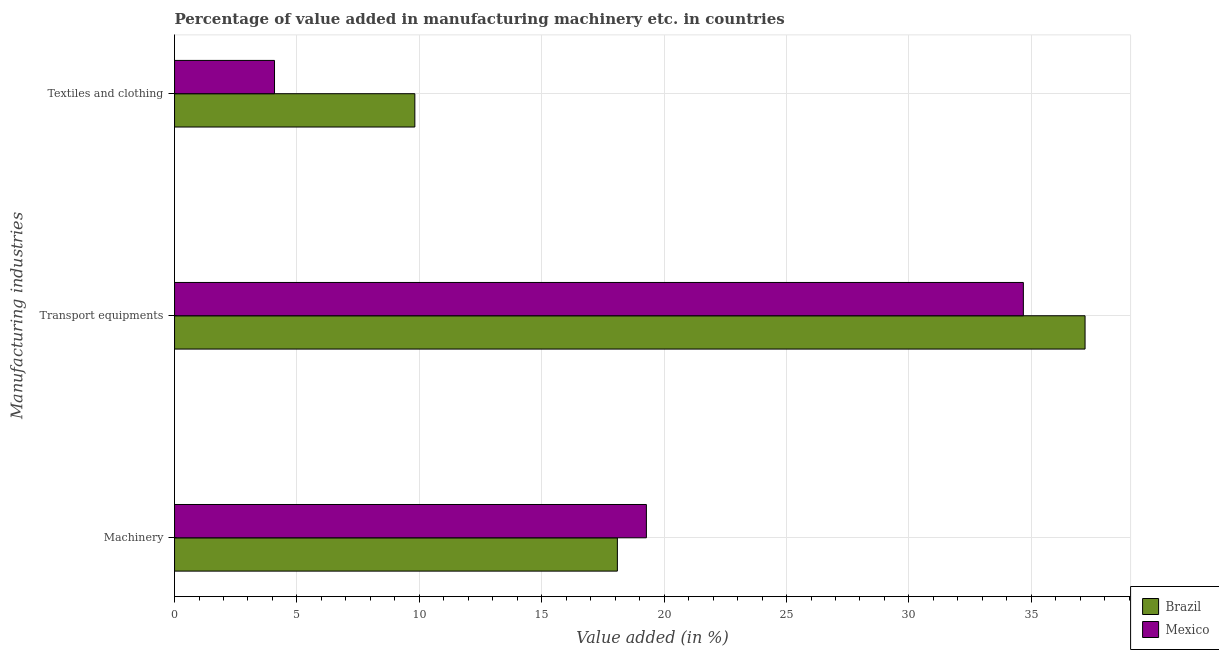How many groups of bars are there?
Give a very brief answer. 3. How many bars are there on the 3rd tick from the bottom?
Give a very brief answer. 2. What is the label of the 1st group of bars from the top?
Keep it short and to the point. Textiles and clothing. What is the value added in manufacturing machinery in Brazil?
Provide a short and direct response. 18.09. Across all countries, what is the maximum value added in manufacturing transport equipments?
Your answer should be compact. 37.2. Across all countries, what is the minimum value added in manufacturing transport equipments?
Keep it short and to the point. 34.68. In which country was the value added in manufacturing textile and clothing minimum?
Your answer should be compact. Mexico. What is the total value added in manufacturing machinery in the graph?
Your response must be concise. 37.37. What is the difference between the value added in manufacturing machinery in Brazil and that in Mexico?
Ensure brevity in your answer.  -1.19. What is the difference between the value added in manufacturing transport equipments in Mexico and the value added in manufacturing machinery in Brazil?
Your response must be concise. 16.59. What is the average value added in manufacturing textile and clothing per country?
Keep it short and to the point. 6.95. What is the difference between the value added in manufacturing transport equipments and value added in manufacturing machinery in Brazil?
Offer a terse response. 19.11. In how many countries, is the value added in manufacturing textile and clothing greater than 25 %?
Your answer should be compact. 0. What is the ratio of the value added in manufacturing machinery in Brazil to that in Mexico?
Your answer should be very brief. 0.94. Is the value added in manufacturing transport equipments in Brazil less than that in Mexico?
Ensure brevity in your answer.  No. Is the difference between the value added in manufacturing textile and clothing in Brazil and Mexico greater than the difference between the value added in manufacturing machinery in Brazil and Mexico?
Your response must be concise. Yes. What is the difference between the highest and the second highest value added in manufacturing textile and clothing?
Make the answer very short. 5.73. What is the difference between the highest and the lowest value added in manufacturing textile and clothing?
Provide a short and direct response. 5.73. In how many countries, is the value added in manufacturing textile and clothing greater than the average value added in manufacturing textile and clothing taken over all countries?
Your answer should be compact. 1. What does the 1st bar from the bottom in Machinery represents?
Offer a terse response. Brazil. Is it the case that in every country, the sum of the value added in manufacturing machinery and value added in manufacturing transport equipments is greater than the value added in manufacturing textile and clothing?
Your answer should be very brief. Yes. Are all the bars in the graph horizontal?
Your answer should be very brief. Yes. How many countries are there in the graph?
Your response must be concise. 2. What is the difference between two consecutive major ticks on the X-axis?
Offer a terse response. 5. Does the graph contain any zero values?
Give a very brief answer. No. Does the graph contain grids?
Make the answer very short. Yes. Where does the legend appear in the graph?
Your answer should be very brief. Bottom right. How many legend labels are there?
Give a very brief answer. 2. What is the title of the graph?
Keep it short and to the point. Percentage of value added in manufacturing machinery etc. in countries. What is the label or title of the X-axis?
Keep it short and to the point. Value added (in %). What is the label or title of the Y-axis?
Your response must be concise. Manufacturing industries. What is the Value added (in %) of Brazil in Machinery?
Provide a short and direct response. 18.09. What is the Value added (in %) in Mexico in Machinery?
Offer a terse response. 19.28. What is the Value added (in %) of Brazil in Transport equipments?
Your answer should be very brief. 37.2. What is the Value added (in %) in Mexico in Transport equipments?
Offer a terse response. 34.68. What is the Value added (in %) of Brazil in Textiles and clothing?
Your answer should be very brief. 9.82. What is the Value added (in %) of Mexico in Textiles and clothing?
Offer a very short reply. 4.08. Across all Manufacturing industries, what is the maximum Value added (in %) in Brazil?
Provide a short and direct response. 37.2. Across all Manufacturing industries, what is the maximum Value added (in %) in Mexico?
Your answer should be very brief. 34.68. Across all Manufacturing industries, what is the minimum Value added (in %) of Brazil?
Offer a very short reply. 9.82. Across all Manufacturing industries, what is the minimum Value added (in %) in Mexico?
Make the answer very short. 4.08. What is the total Value added (in %) of Brazil in the graph?
Offer a very short reply. 65.1. What is the total Value added (in %) in Mexico in the graph?
Your response must be concise. 58.03. What is the difference between the Value added (in %) in Brazil in Machinery and that in Transport equipments?
Keep it short and to the point. -19.11. What is the difference between the Value added (in %) of Mexico in Machinery and that in Transport equipments?
Your answer should be very brief. -15.4. What is the difference between the Value added (in %) of Brazil in Machinery and that in Textiles and clothing?
Offer a terse response. 8.27. What is the difference between the Value added (in %) in Mexico in Machinery and that in Textiles and clothing?
Provide a short and direct response. 15.19. What is the difference between the Value added (in %) in Brazil in Transport equipments and that in Textiles and clothing?
Make the answer very short. 27.38. What is the difference between the Value added (in %) in Mexico in Transport equipments and that in Textiles and clothing?
Keep it short and to the point. 30.59. What is the difference between the Value added (in %) of Brazil in Machinery and the Value added (in %) of Mexico in Transport equipments?
Provide a succinct answer. -16.59. What is the difference between the Value added (in %) of Brazil in Machinery and the Value added (in %) of Mexico in Textiles and clothing?
Ensure brevity in your answer.  14.01. What is the difference between the Value added (in %) of Brazil in Transport equipments and the Value added (in %) of Mexico in Textiles and clothing?
Give a very brief answer. 33.11. What is the average Value added (in %) of Brazil per Manufacturing industries?
Your answer should be compact. 21.7. What is the average Value added (in %) of Mexico per Manufacturing industries?
Give a very brief answer. 19.34. What is the difference between the Value added (in %) of Brazil and Value added (in %) of Mexico in Machinery?
Give a very brief answer. -1.19. What is the difference between the Value added (in %) in Brazil and Value added (in %) in Mexico in Transport equipments?
Your answer should be very brief. 2.52. What is the difference between the Value added (in %) of Brazil and Value added (in %) of Mexico in Textiles and clothing?
Your answer should be compact. 5.73. What is the ratio of the Value added (in %) of Brazil in Machinery to that in Transport equipments?
Your response must be concise. 0.49. What is the ratio of the Value added (in %) of Mexico in Machinery to that in Transport equipments?
Provide a succinct answer. 0.56. What is the ratio of the Value added (in %) in Brazil in Machinery to that in Textiles and clothing?
Your answer should be very brief. 1.84. What is the ratio of the Value added (in %) of Mexico in Machinery to that in Textiles and clothing?
Offer a terse response. 4.72. What is the ratio of the Value added (in %) in Brazil in Transport equipments to that in Textiles and clothing?
Give a very brief answer. 3.79. What is the ratio of the Value added (in %) in Mexico in Transport equipments to that in Textiles and clothing?
Keep it short and to the point. 8.49. What is the difference between the highest and the second highest Value added (in %) in Brazil?
Provide a short and direct response. 19.11. What is the difference between the highest and the second highest Value added (in %) of Mexico?
Keep it short and to the point. 15.4. What is the difference between the highest and the lowest Value added (in %) of Brazil?
Give a very brief answer. 27.38. What is the difference between the highest and the lowest Value added (in %) of Mexico?
Provide a succinct answer. 30.59. 